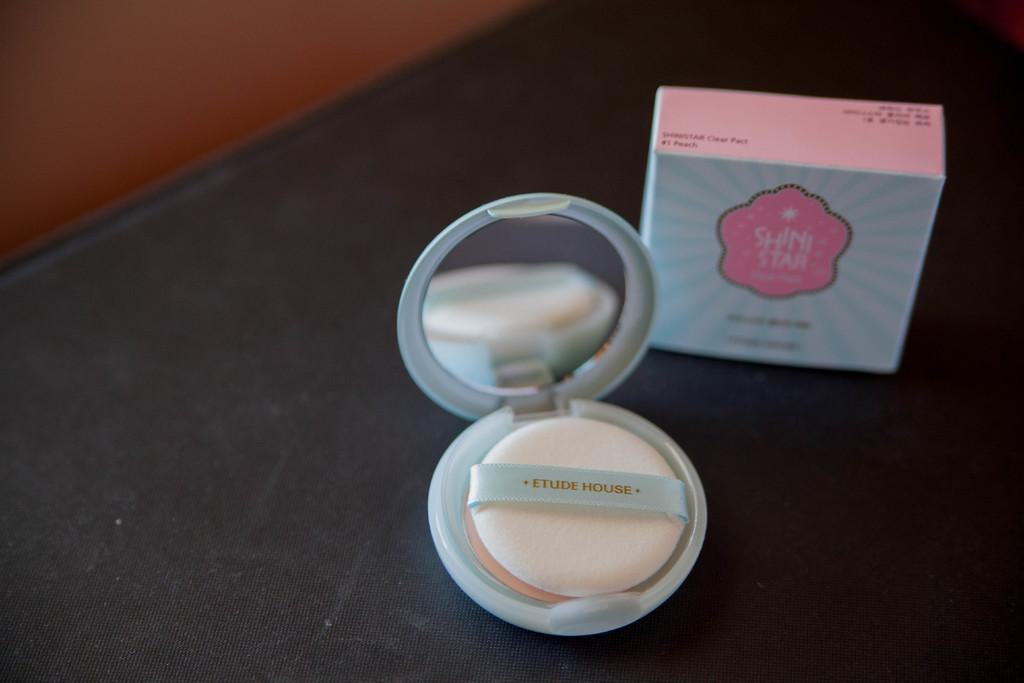<image>
Relay a brief, clear account of the picture shown. the word shini is on the item that is pink 